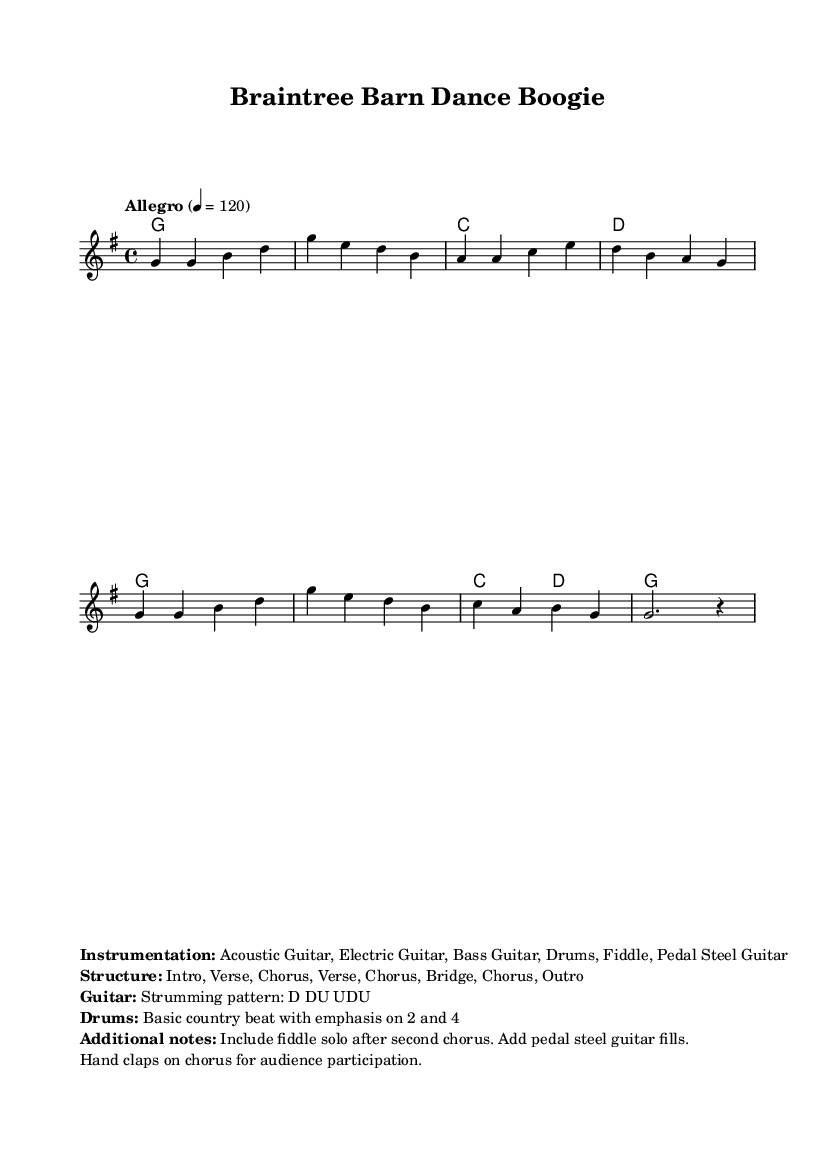What is the key signature of this music? The key signature shows one sharp, indicating that the piece is in G major.
Answer: G major What is the time signature of this music? The time signature is indicated as 4/4, meaning there are four beats in each measure and the quarter note receives one beat.
Answer: 4/4 What is the tempo marking of this music? The tempo marking indicates "Allegro" and provides a tempo of 120 beats per minute, which suggests a fast and lively pace for the performance.
Answer: Allegro 4 = 120 How many sections are in the song structure? The structure is specified as Intro, Verse, Chorus, Verse, Chorus, Bridge, Chorus, Outro, totaling eight distinct sections.
Answer: Eight What is the primary role of the drums in this piece? The drums play a basic country beat with emphasis on beats 2 and 4, which is characteristic of country music dance rhythms.
Answer: Basic country beat What additional instrumentation is mentioned for the performance? The sheet music includes Acoustic Guitar, Electric Guitar, Bass Guitar, Drums, Fiddle, and Pedal Steel Guitar, adding rich textures typical in country music.
Answer: Acoustic Guitar, Electric Guitar, Bass Guitar, Drums, Fiddle, Pedal Steel Guitar What is the suggested audience participation element during the chorus? The instructions specify including hand claps on the chorus, enhancing audience engagement during live performances.
Answer: Hand claps 